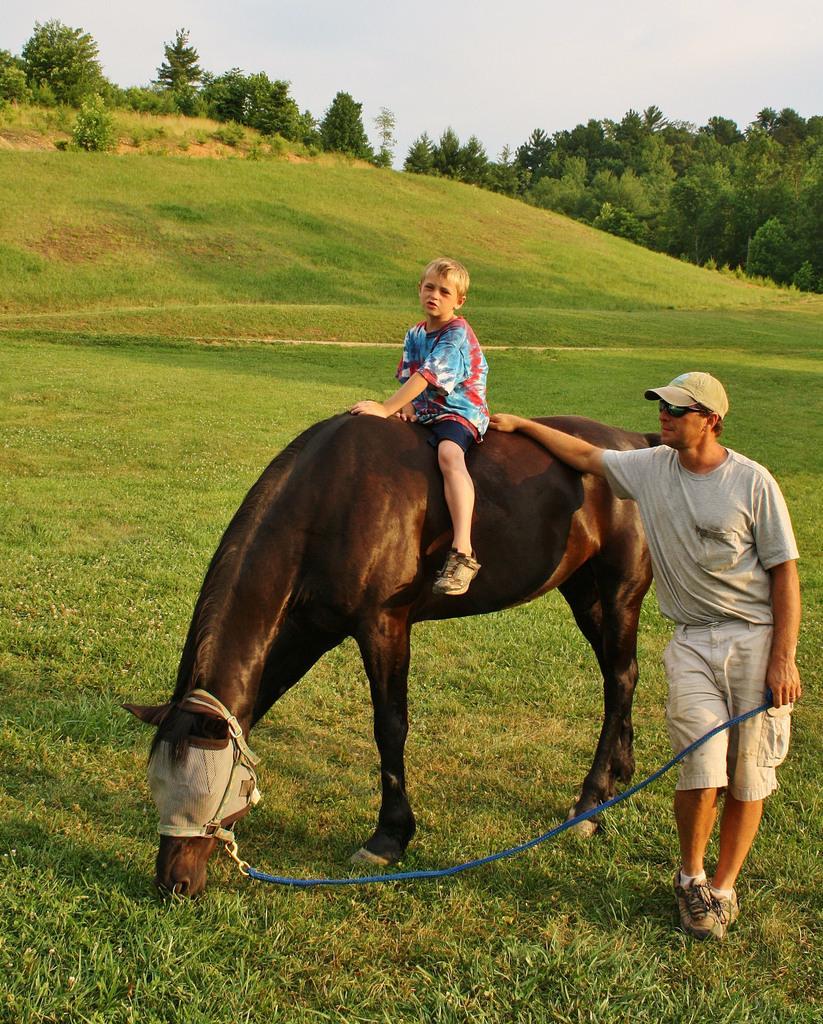Please provide a concise description of this image. This person standing and holding rope. This kid sitting on the horse. This is grass. We can see trees and sky. This person wear cap and glasses. 